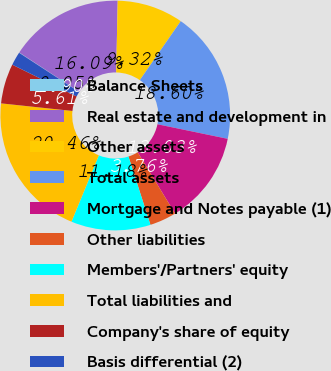<chart> <loc_0><loc_0><loc_500><loc_500><pie_chart><fcel>Balance Sheets<fcel>Real estate and development in<fcel>Other assets<fcel>Total assets<fcel>Mortgage and Notes payable (1)<fcel>Other liabilities<fcel>Members'/Partners' equity<fcel>Total liabilities and<fcel>Company's share of equity<fcel>Basis differential (2)<nl><fcel>0.05%<fcel>16.09%<fcel>9.32%<fcel>18.6%<fcel>13.03%<fcel>3.76%<fcel>11.18%<fcel>20.46%<fcel>5.61%<fcel>1.9%<nl></chart> 